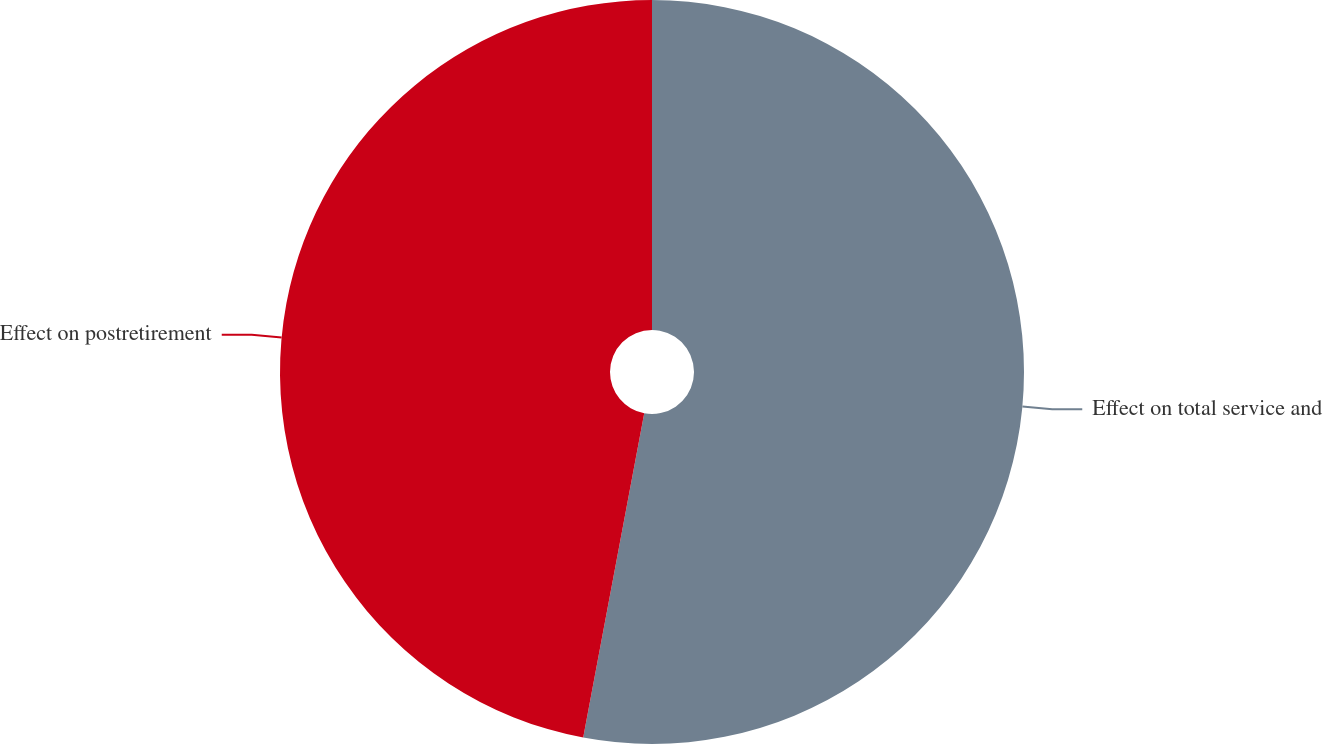Convert chart. <chart><loc_0><loc_0><loc_500><loc_500><pie_chart><fcel>Effect on total service and<fcel>Effect on postretirement<nl><fcel>52.96%<fcel>47.04%<nl></chart> 